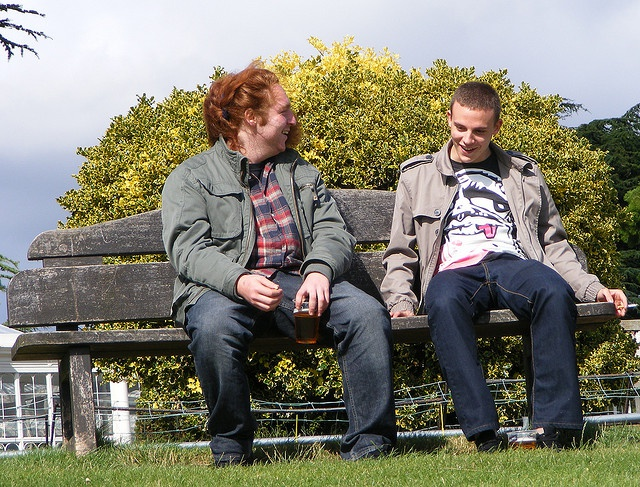Describe the objects in this image and their specific colors. I can see people in white, black, darkgray, gray, and maroon tones, people in white, black, lightgray, and gray tones, bench in white, gray, black, and darkgray tones, and cup in white, black, maroon, gray, and brown tones in this image. 